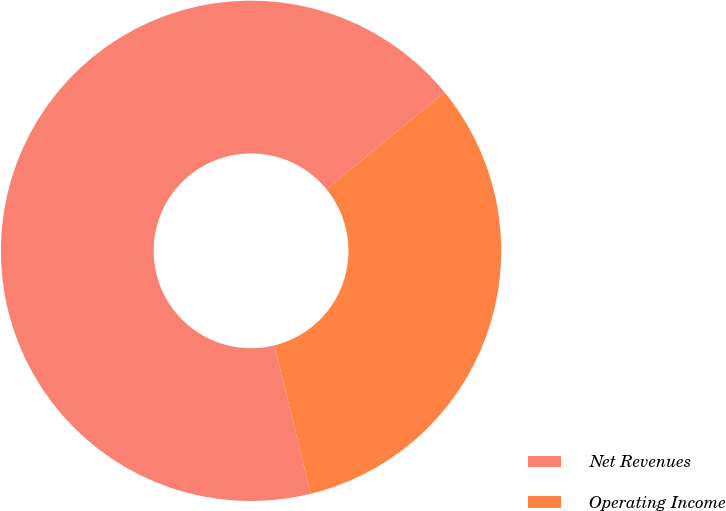<chart> <loc_0><loc_0><loc_500><loc_500><pie_chart><fcel>Net Revenues<fcel>Operating Income<nl><fcel>67.92%<fcel>32.08%<nl></chart> 